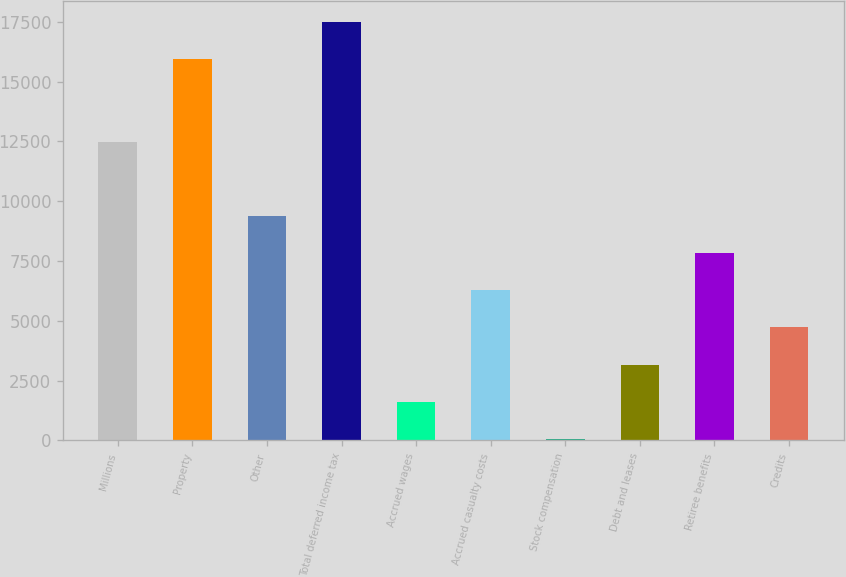Convert chart to OTSL. <chart><loc_0><loc_0><loc_500><loc_500><bar_chart><fcel>Millions<fcel>Property<fcel>Other<fcel>Total deferred income tax<fcel>Accrued wages<fcel>Accrued casualty costs<fcel>Stock compensation<fcel>Debt and leases<fcel>Retiree benefits<fcel>Credits<nl><fcel>12481<fcel>15954.5<fcel>9378<fcel>17506<fcel>1620.5<fcel>6275<fcel>69<fcel>3172<fcel>7826.5<fcel>4723.5<nl></chart> 